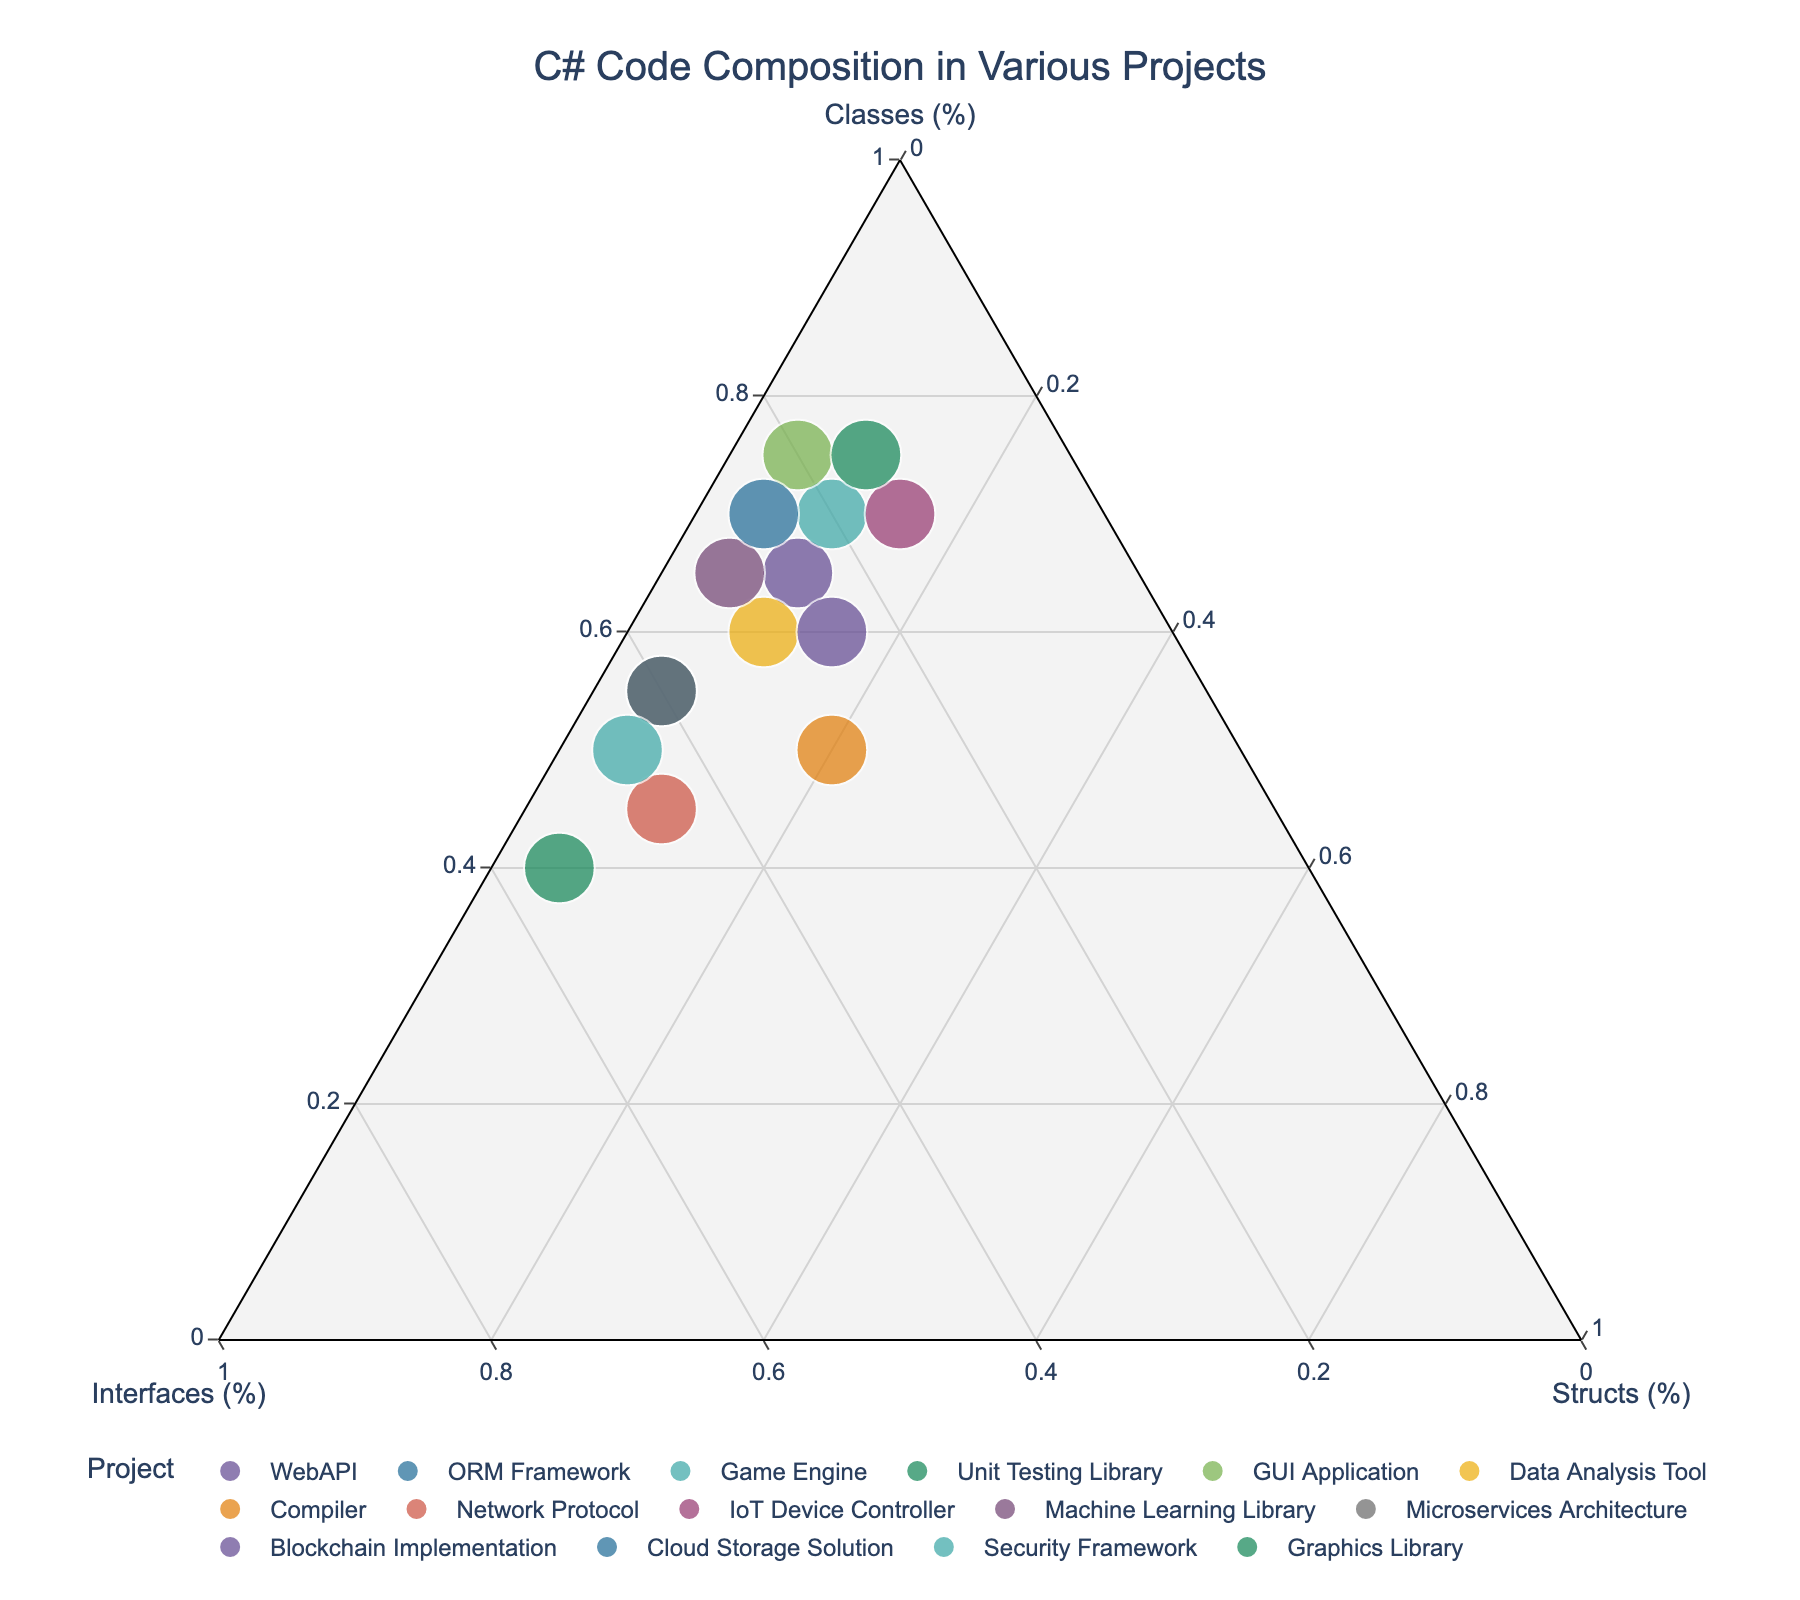What project has the highest percentage of classes? Look at the 'Classes (%)' axis on the ternary plot and find the data point farthest along that axis. The GUI Application, with 75% classes, is farthest along that axis.
Answer: GUI Application Which projects have over 40% of interfaces? Check the 'Interfaces (%)' axis and identify the points that are beyond the 40% mark. The Unit Testing Library and Security Framework projects have more than 40% of interfaces.
Answer: Unit Testing Library, Security Framework What is the relationship between the Game Engine and IoT Device Controller in terms of structs? Look at the 'Structs (%)' axis values for both projects. The Game Engine has 10% structs, and the IoT Device Controller has 15% structs, meaning the IoT Device Controller has a higher percentage of structs.
Answer: IoT Device Controller has more structs Which project has the smallest total number of elements and what is its distribution? Find the smallest sized data point (as size represents the total number of elements). The Unit Testing Library has the smallest size with proportions of 40% classes, 55% interfaces, and 5% structs.
Answer: Unit Testing Library, 40% classes, 55% interfaces, 5% structs What percentage of elements do structs make up in the Cloud Storage Solution project? Locate the Cloud Storage Solution project on the plot and read the 'Structs (%)' value, which is 5%.
Answer: 5% Of the projects which have between 65-75% classes, how many have more than 5% structs? Identify the data points within 65-75% range along the 'Classes (%)' axis, and then check their 'Structs (%)' values. The projects are GUI Application, Data Analysis Tool, IoT Device Controller, and Graphics Library. Of these, Data Analysis Tool and IoT Device Controller have more than 5% structs.
Answer: 2 projects Which project has an equal percentage of classes and interfaces, and what is the percentage of structs? Find the project where the points on the 'Classes (%)' and 'Interfaces (%)' axes are the same. The Network Protocol project has equal proportions with 45% each for classes and interfaces and 10% for structs.
Answer: Network Protocol, 10% For the Machine Learning Library, calculate the combined percentage of classes and structs. Look up the values on the plot: the percentage for classes is 65% and for structs is 5%. Adding them together gives 70%.
Answer: 70% What is the difference in the percentage of interfaces between the Compiler and the Blockchain Implementation? Check the 'Interfaces (%)' values for both projects from the plot. The Compiler has 30% interfaces and the Blockchain Implementation has 25% interfaces, leading to a 5% difference.
Answer: 5% Which project has a higher proportion of structs, the Network Protocol or the Compiler? Compare the 'Structs (%)' values: the Network Protocol has 10% and the Compiler has 20%, hence the Compiler has a higher proportion of structs.
Answer: Compiler 